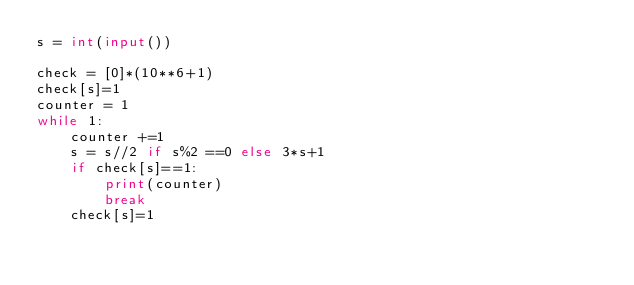<code> <loc_0><loc_0><loc_500><loc_500><_Python_>s = int(input())

check = [0]*(10**6+1)
check[s]=1
counter = 1
while 1:
    counter +=1
    s = s//2 if s%2 ==0 else 3*s+1
    if check[s]==1:
        print(counter)
        break
    check[s]=1
</code> 